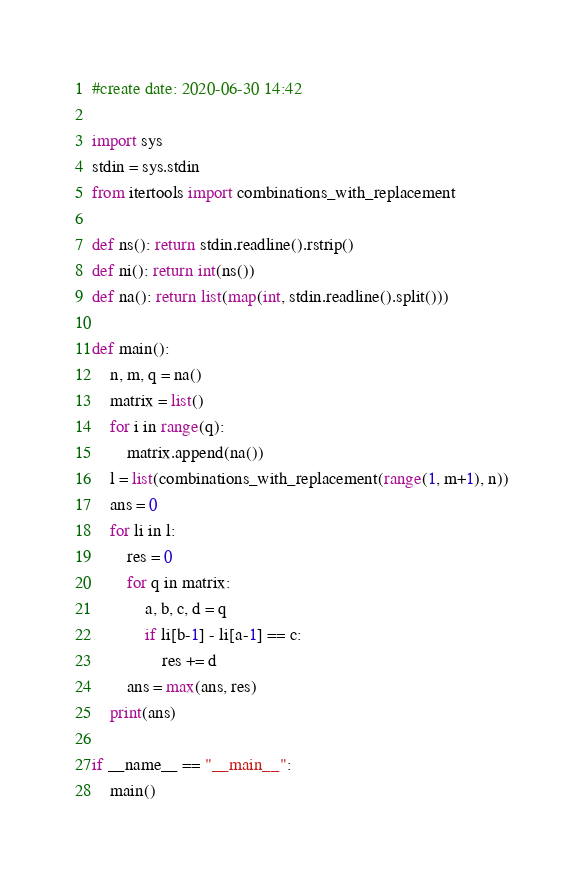Convert code to text. <code><loc_0><loc_0><loc_500><loc_500><_Python_>#create date: 2020-06-30 14:42

import sys
stdin = sys.stdin
from itertools import combinations_with_replacement

def ns(): return stdin.readline().rstrip()
def ni(): return int(ns())
def na(): return list(map(int, stdin.readline().split()))

def main():
    n, m, q = na()
    matrix = list()
    for i in range(q):
        matrix.append(na())
    l = list(combinations_with_replacement(range(1, m+1), n))
    ans = 0
    for li in l:
        res = 0
        for q in matrix:
            a, b, c, d = q
            if li[b-1] - li[a-1] == c:
                res += d
        ans = max(ans, res)
    print(ans)

if __name__ == "__main__":
    main()</code> 